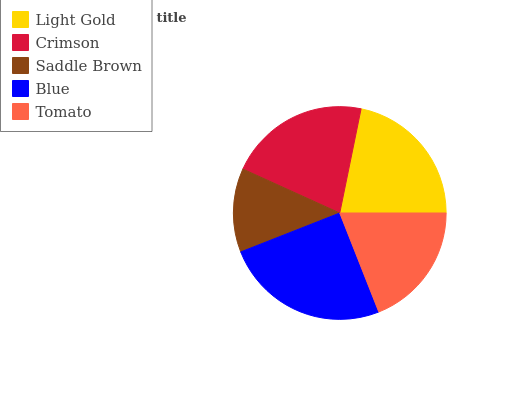Is Saddle Brown the minimum?
Answer yes or no. Yes. Is Blue the maximum?
Answer yes or no. Yes. Is Crimson the minimum?
Answer yes or no. No. Is Crimson the maximum?
Answer yes or no. No. Is Light Gold greater than Crimson?
Answer yes or no. Yes. Is Crimson less than Light Gold?
Answer yes or no. Yes. Is Crimson greater than Light Gold?
Answer yes or no. No. Is Light Gold less than Crimson?
Answer yes or no. No. Is Crimson the high median?
Answer yes or no. Yes. Is Crimson the low median?
Answer yes or no. Yes. Is Saddle Brown the high median?
Answer yes or no. No. Is Light Gold the low median?
Answer yes or no. No. 